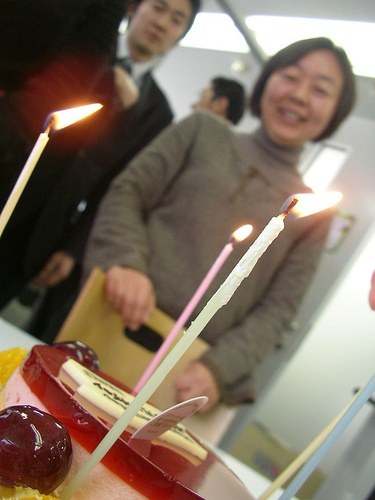Describe the objects in this image and their specific colors. I can see people in black, gray, and tan tones, people in black, maroon, and gray tones, dining table in black, maroon, brown, and tan tones, chair in black, tan, olive, and gray tones, and people in black and gray tones in this image. 